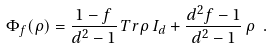Convert formula to latex. <formula><loc_0><loc_0><loc_500><loc_500>\Phi _ { f } ( \rho ) = \frac { 1 - f } { d ^ { 2 } - 1 } \, T r \rho \, I _ { d } + \frac { d ^ { 2 } f - 1 } { d ^ { 2 } - 1 } \, \rho \ .</formula> 